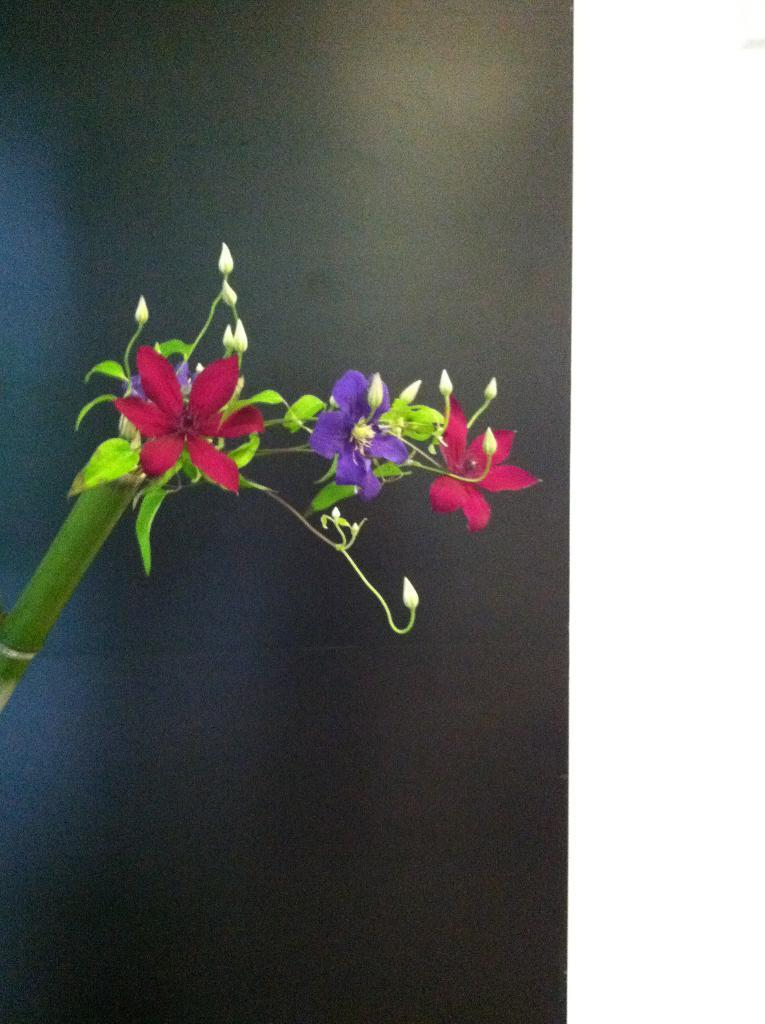What colors are the flowers in the image? There are red and purple flowers in the image. What other parts of the plants can be seen in the image besides the flowers? Leaves and stems are visible in the image. What type of veil is draped over the flowers in the image? There is no veil present in the image; it only features flowers, leaves, and stems. 